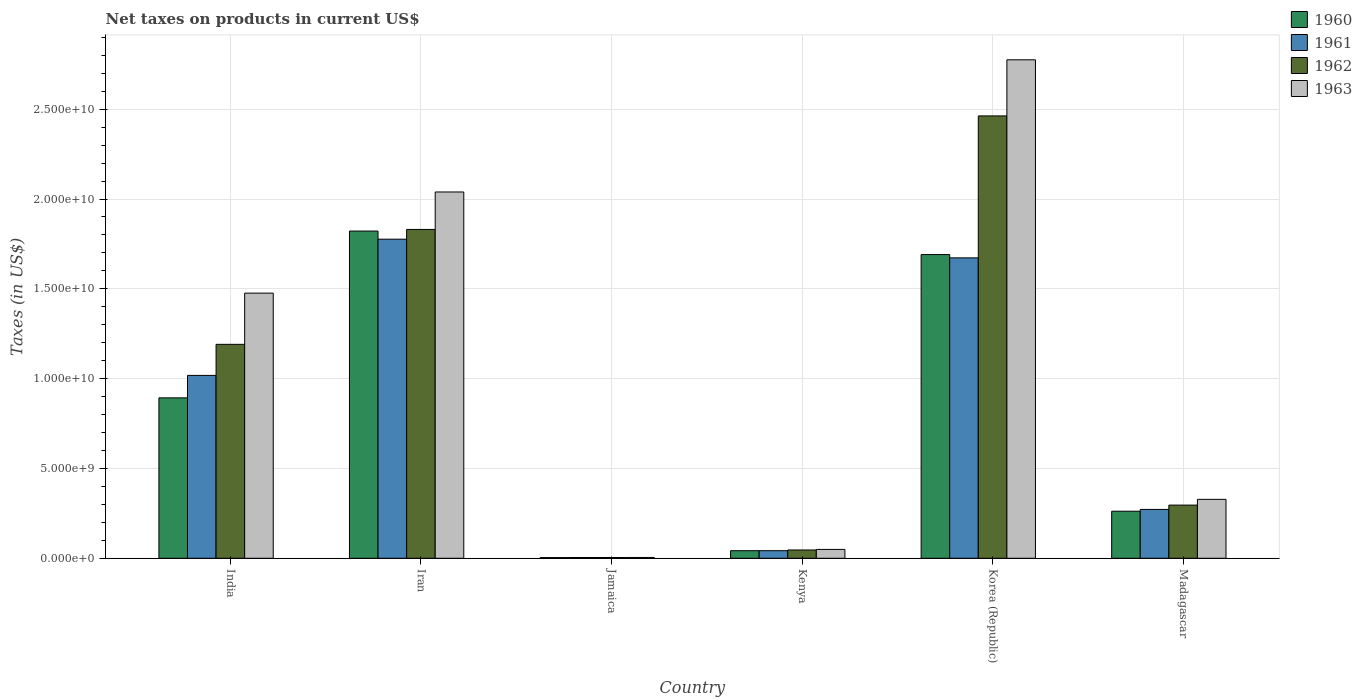How many different coloured bars are there?
Your answer should be compact. 4. How many groups of bars are there?
Offer a terse response. 6. Are the number of bars per tick equal to the number of legend labels?
Make the answer very short. Yes. Are the number of bars on each tick of the X-axis equal?
Provide a succinct answer. Yes. How many bars are there on the 4th tick from the left?
Your response must be concise. 4. How many bars are there on the 5th tick from the right?
Your answer should be very brief. 4. What is the label of the 5th group of bars from the left?
Offer a very short reply. Korea (Republic). In how many cases, is the number of bars for a given country not equal to the number of legend labels?
Your answer should be compact. 0. What is the net taxes on products in 1962 in India?
Make the answer very short. 1.19e+1. Across all countries, what is the maximum net taxes on products in 1960?
Offer a terse response. 1.82e+1. Across all countries, what is the minimum net taxes on products in 1963?
Keep it short and to the point. 4.54e+07. In which country was the net taxes on products in 1960 maximum?
Keep it short and to the point. Iran. In which country was the net taxes on products in 1963 minimum?
Offer a very short reply. Jamaica. What is the total net taxes on products in 1961 in the graph?
Offer a terse response. 4.79e+1. What is the difference between the net taxes on products in 1960 in India and that in Korea (Republic)?
Your response must be concise. -7.98e+09. What is the difference between the net taxes on products in 1961 in Madagascar and the net taxes on products in 1960 in Kenya?
Offer a terse response. 2.30e+09. What is the average net taxes on products in 1960 per country?
Provide a succinct answer. 7.86e+09. What is the difference between the net taxes on products of/in 1962 and net taxes on products of/in 1961 in India?
Provide a succinct answer. 1.73e+09. What is the ratio of the net taxes on products in 1963 in Kenya to that in Korea (Republic)?
Keep it short and to the point. 0.02. Is the net taxes on products in 1963 in India less than that in Madagascar?
Your answer should be very brief. No. What is the difference between the highest and the second highest net taxes on products in 1962?
Keep it short and to the point. -1.27e+1. What is the difference between the highest and the lowest net taxes on products in 1961?
Your answer should be very brief. 1.77e+1. In how many countries, is the net taxes on products in 1961 greater than the average net taxes on products in 1961 taken over all countries?
Provide a short and direct response. 3. Is the sum of the net taxes on products in 1960 in India and Kenya greater than the maximum net taxes on products in 1961 across all countries?
Provide a short and direct response. No. Is it the case that in every country, the sum of the net taxes on products in 1961 and net taxes on products in 1960 is greater than the sum of net taxes on products in 1962 and net taxes on products in 1963?
Offer a terse response. No. What does the 3rd bar from the left in India represents?
Offer a terse response. 1962. Is it the case that in every country, the sum of the net taxes on products in 1961 and net taxes on products in 1960 is greater than the net taxes on products in 1963?
Provide a succinct answer. Yes. Are all the bars in the graph horizontal?
Provide a succinct answer. No. How many countries are there in the graph?
Offer a very short reply. 6. Does the graph contain any zero values?
Your answer should be compact. No. Where does the legend appear in the graph?
Make the answer very short. Top right. How many legend labels are there?
Ensure brevity in your answer.  4. How are the legend labels stacked?
Provide a succinct answer. Vertical. What is the title of the graph?
Ensure brevity in your answer.  Net taxes on products in current US$. What is the label or title of the Y-axis?
Your answer should be compact. Taxes (in US$). What is the Taxes (in US$) of 1960 in India?
Your answer should be very brief. 8.93e+09. What is the Taxes (in US$) of 1961 in India?
Your response must be concise. 1.02e+1. What is the Taxes (in US$) in 1962 in India?
Your answer should be compact. 1.19e+1. What is the Taxes (in US$) of 1963 in India?
Provide a succinct answer. 1.48e+1. What is the Taxes (in US$) of 1960 in Iran?
Your answer should be very brief. 1.82e+1. What is the Taxes (in US$) in 1961 in Iran?
Ensure brevity in your answer.  1.78e+1. What is the Taxes (in US$) in 1962 in Iran?
Give a very brief answer. 1.83e+1. What is the Taxes (in US$) of 1963 in Iran?
Give a very brief answer. 2.04e+1. What is the Taxes (in US$) of 1960 in Jamaica?
Make the answer very short. 3.93e+07. What is the Taxes (in US$) in 1961 in Jamaica?
Provide a succinct answer. 4.26e+07. What is the Taxes (in US$) in 1962 in Jamaica?
Your response must be concise. 4.35e+07. What is the Taxes (in US$) in 1963 in Jamaica?
Provide a short and direct response. 4.54e+07. What is the Taxes (in US$) of 1960 in Kenya?
Provide a short and direct response. 4.21e+08. What is the Taxes (in US$) in 1961 in Kenya?
Your answer should be very brief. 4.22e+08. What is the Taxes (in US$) of 1962 in Kenya?
Your answer should be compact. 4.62e+08. What is the Taxes (in US$) of 1963 in Kenya?
Provide a short and direct response. 4.93e+08. What is the Taxes (in US$) in 1960 in Korea (Republic)?
Make the answer very short. 1.69e+1. What is the Taxes (in US$) of 1961 in Korea (Republic)?
Your answer should be compact. 1.67e+1. What is the Taxes (in US$) in 1962 in Korea (Republic)?
Give a very brief answer. 2.46e+1. What is the Taxes (in US$) of 1963 in Korea (Republic)?
Make the answer very short. 2.77e+1. What is the Taxes (in US$) in 1960 in Madagascar?
Ensure brevity in your answer.  2.62e+09. What is the Taxes (in US$) in 1961 in Madagascar?
Offer a very short reply. 2.72e+09. What is the Taxes (in US$) in 1962 in Madagascar?
Give a very brief answer. 2.96e+09. What is the Taxes (in US$) in 1963 in Madagascar?
Your answer should be very brief. 3.28e+09. Across all countries, what is the maximum Taxes (in US$) in 1960?
Your response must be concise. 1.82e+1. Across all countries, what is the maximum Taxes (in US$) of 1961?
Provide a succinct answer. 1.78e+1. Across all countries, what is the maximum Taxes (in US$) of 1962?
Offer a terse response. 2.46e+1. Across all countries, what is the maximum Taxes (in US$) in 1963?
Provide a short and direct response. 2.77e+1. Across all countries, what is the minimum Taxes (in US$) of 1960?
Provide a succinct answer. 3.93e+07. Across all countries, what is the minimum Taxes (in US$) in 1961?
Your response must be concise. 4.26e+07. Across all countries, what is the minimum Taxes (in US$) of 1962?
Your answer should be compact. 4.35e+07. Across all countries, what is the minimum Taxes (in US$) in 1963?
Make the answer very short. 4.54e+07. What is the total Taxes (in US$) in 1960 in the graph?
Your answer should be very brief. 4.71e+1. What is the total Taxes (in US$) of 1961 in the graph?
Provide a short and direct response. 4.79e+1. What is the total Taxes (in US$) in 1962 in the graph?
Keep it short and to the point. 5.83e+1. What is the total Taxes (in US$) of 1963 in the graph?
Offer a very short reply. 6.67e+1. What is the difference between the Taxes (in US$) in 1960 in India and that in Iran?
Keep it short and to the point. -9.29e+09. What is the difference between the Taxes (in US$) of 1961 in India and that in Iran?
Ensure brevity in your answer.  -7.58e+09. What is the difference between the Taxes (in US$) of 1962 in India and that in Iran?
Ensure brevity in your answer.  -6.40e+09. What is the difference between the Taxes (in US$) in 1963 in India and that in Iran?
Ensure brevity in your answer.  -5.63e+09. What is the difference between the Taxes (in US$) in 1960 in India and that in Jamaica?
Ensure brevity in your answer.  8.89e+09. What is the difference between the Taxes (in US$) of 1961 in India and that in Jamaica?
Provide a short and direct response. 1.01e+1. What is the difference between the Taxes (in US$) of 1962 in India and that in Jamaica?
Your answer should be compact. 1.19e+1. What is the difference between the Taxes (in US$) of 1963 in India and that in Jamaica?
Make the answer very short. 1.47e+1. What is the difference between the Taxes (in US$) in 1960 in India and that in Kenya?
Make the answer very short. 8.51e+09. What is the difference between the Taxes (in US$) of 1961 in India and that in Kenya?
Make the answer very short. 9.76e+09. What is the difference between the Taxes (in US$) in 1962 in India and that in Kenya?
Your answer should be compact. 1.14e+1. What is the difference between the Taxes (in US$) in 1963 in India and that in Kenya?
Ensure brevity in your answer.  1.43e+1. What is the difference between the Taxes (in US$) of 1960 in India and that in Korea (Republic)?
Your answer should be compact. -7.98e+09. What is the difference between the Taxes (in US$) in 1961 in India and that in Korea (Republic)?
Make the answer very short. -6.54e+09. What is the difference between the Taxes (in US$) in 1962 in India and that in Korea (Republic)?
Provide a succinct answer. -1.27e+1. What is the difference between the Taxes (in US$) of 1963 in India and that in Korea (Republic)?
Keep it short and to the point. -1.30e+1. What is the difference between the Taxes (in US$) in 1960 in India and that in Madagascar?
Ensure brevity in your answer.  6.31e+09. What is the difference between the Taxes (in US$) in 1961 in India and that in Madagascar?
Your answer should be very brief. 7.46e+09. What is the difference between the Taxes (in US$) in 1962 in India and that in Madagascar?
Provide a short and direct response. 8.95e+09. What is the difference between the Taxes (in US$) in 1963 in India and that in Madagascar?
Make the answer very short. 1.15e+1. What is the difference between the Taxes (in US$) in 1960 in Iran and that in Jamaica?
Offer a very short reply. 1.82e+1. What is the difference between the Taxes (in US$) in 1961 in Iran and that in Jamaica?
Offer a very short reply. 1.77e+1. What is the difference between the Taxes (in US$) of 1962 in Iran and that in Jamaica?
Offer a terse response. 1.83e+1. What is the difference between the Taxes (in US$) of 1963 in Iran and that in Jamaica?
Keep it short and to the point. 2.03e+1. What is the difference between the Taxes (in US$) of 1960 in Iran and that in Kenya?
Make the answer very short. 1.78e+1. What is the difference between the Taxes (in US$) in 1961 in Iran and that in Kenya?
Offer a very short reply. 1.73e+1. What is the difference between the Taxes (in US$) in 1962 in Iran and that in Kenya?
Offer a terse response. 1.78e+1. What is the difference between the Taxes (in US$) in 1963 in Iran and that in Kenya?
Give a very brief answer. 1.99e+1. What is the difference between the Taxes (in US$) of 1960 in Iran and that in Korea (Republic)?
Keep it short and to the point. 1.31e+09. What is the difference between the Taxes (in US$) in 1961 in Iran and that in Korea (Republic)?
Keep it short and to the point. 1.04e+09. What is the difference between the Taxes (in US$) of 1962 in Iran and that in Korea (Republic)?
Your answer should be very brief. -6.32e+09. What is the difference between the Taxes (in US$) of 1963 in Iran and that in Korea (Republic)?
Keep it short and to the point. -7.36e+09. What is the difference between the Taxes (in US$) of 1960 in Iran and that in Madagascar?
Ensure brevity in your answer.  1.56e+1. What is the difference between the Taxes (in US$) in 1961 in Iran and that in Madagascar?
Offer a terse response. 1.50e+1. What is the difference between the Taxes (in US$) in 1962 in Iran and that in Madagascar?
Your answer should be very brief. 1.53e+1. What is the difference between the Taxes (in US$) of 1963 in Iran and that in Madagascar?
Your answer should be compact. 1.71e+1. What is the difference between the Taxes (in US$) in 1960 in Jamaica and that in Kenya?
Give a very brief answer. -3.82e+08. What is the difference between the Taxes (in US$) in 1961 in Jamaica and that in Kenya?
Keep it short and to the point. -3.79e+08. What is the difference between the Taxes (in US$) of 1962 in Jamaica and that in Kenya?
Keep it short and to the point. -4.18e+08. What is the difference between the Taxes (in US$) of 1963 in Jamaica and that in Kenya?
Your answer should be compact. -4.48e+08. What is the difference between the Taxes (in US$) of 1960 in Jamaica and that in Korea (Republic)?
Offer a terse response. -1.69e+1. What is the difference between the Taxes (in US$) in 1961 in Jamaica and that in Korea (Republic)?
Offer a very short reply. -1.67e+1. What is the difference between the Taxes (in US$) in 1962 in Jamaica and that in Korea (Republic)?
Give a very brief answer. -2.46e+1. What is the difference between the Taxes (in US$) in 1963 in Jamaica and that in Korea (Republic)?
Keep it short and to the point. -2.77e+1. What is the difference between the Taxes (in US$) of 1960 in Jamaica and that in Madagascar?
Offer a terse response. -2.58e+09. What is the difference between the Taxes (in US$) in 1961 in Jamaica and that in Madagascar?
Keep it short and to the point. -2.68e+09. What is the difference between the Taxes (in US$) in 1962 in Jamaica and that in Madagascar?
Your answer should be very brief. -2.92e+09. What is the difference between the Taxes (in US$) in 1963 in Jamaica and that in Madagascar?
Your answer should be very brief. -3.23e+09. What is the difference between the Taxes (in US$) of 1960 in Kenya and that in Korea (Republic)?
Keep it short and to the point. -1.65e+1. What is the difference between the Taxes (in US$) of 1961 in Kenya and that in Korea (Republic)?
Your response must be concise. -1.63e+1. What is the difference between the Taxes (in US$) in 1962 in Kenya and that in Korea (Republic)?
Ensure brevity in your answer.  -2.42e+1. What is the difference between the Taxes (in US$) of 1963 in Kenya and that in Korea (Republic)?
Your response must be concise. -2.73e+1. What is the difference between the Taxes (in US$) in 1960 in Kenya and that in Madagascar?
Offer a terse response. -2.20e+09. What is the difference between the Taxes (in US$) in 1961 in Kenya and that in Madagascar?
Offer a terse response. -2.30e+09. What is the difference between the Taxes (in US$) of 1962 in Kenya and that in Madagascar?
Your response must be concise. -2.50e+09. What is the difference between the Taxes (in US$) of 1963 in Kenya and that in Madagascar?
Provide a short and direct response. -2.79e+09. What is the difference between the Taxes (in US$) of 1960 in Korea (Republic) and that in Madagascar?
Your response must be concise. 1.43e+1. What is the difference between the Taxes (in US$) of 1961 in Korea (Republic) and that in Madagascar?
Your answer should be compact. 1.40e+1. What is the difference between the Taxes (in US$) of 1962 in Korea (Republic) and that in Madagascar?
Make the answer very short. 2.17e+1. What is the difference between the Taxes (in US$) of 1963 in Korea (Republic) and that in Madagascar?
Ensure brevity in your answer.  2.45e+1. What is the difference between the Taxes (in US$) of 1960 in India and the Taxes (in US$) of 1961 in Iran?
Ensure brevity in your answer.  -8.83e+09. What is the difference between the Taxes (in US$) of 1960 in India and the Taxes (in US$) of 1962 in Iran?
Ensure brevity in your answer.  -9.38e+09. What is the difference between the Taxes (in US$) in 1960 in India and the Taxes (in US$) in 1963 in Iran?
Offer a terse response. -1.15e+1. What is the difference between the Taxes (in US$) in 1961 in India and the Taxes (in US$) in 1962 in Iran?
Your answer should be very brief. -8.13e+09. What is the difference between the Taxes (in US$) of 1961 in India and the Taxes (in US$) of 1963 in Iran?
Give a very brief answer. -1.02e+1. What is the difference between the Taxes (in US$) of 1962 in India and the Taxes (in US$) of 1963 in Iran?
Offer a very short reply. -8.48e+09. What is the difference between the Taxes (in US$) of 1960 in India and the Taxes (in US$) of 1961 in Jamaica?
Offer a terse response. 8.89e+09. What is the difference between the Taxes (in US$) in 1960 in India and the Taxes (in US$) in 1962 in Jamaica?
Offer a very short reply. 8.89e+09. What is the difference between the Taxes (in US$) in 1960 in India and the Taxes (in US$) in 1963 in Jamaica?
Your response must be concise. 8.88e+09. What is the difference between the Taxes (in US$) of 1961 in India and the Taxes (in US$) of 1962 in Jamaica?
Your answer should be very brief. 1.01e+1. What is the difference between the Taxes (in US$) in 1961 in India and the Taxes (in US$) in 1963 in Jamaica?
Your response must be concise. 1.01e+1. What is the difference between the Taxes (in US$) in 1962 in India and the Taxes (in US$) in 1963 in Jamaica?
Your answer should be compact. 1.19e+1. What is the difference between the Taxes (in US$) of 1960 in India and the Taxes (in US$) of 1961 in Kenya?
Your answer should be very brief. 8.51e+09. What is the difference between the Taxes (in US$) of 1960 in India and the Taxes (in US$) of 1962 in Kenya?
Provide a succinct answer. 8.47e+09. What is the difference between the Taxes (in US$) in 1960 in India and the Taxes (in US$) in 1963 in Kenya?
Provide a succinct answer. 8.44e+09. What is the difference between the Taxes (in US$) of 1961 in India and the Taxes (in US$) of 1962 in Kenya?
Your response must be concise. 9.72e+09. What is the difference between the Taxes (in US$) of 1961 in India and the Taxes (in US$) of 1963 in Kenya?
Make the answer very short. 9.69e+09. What is the difference between the Taxes (in US$) in 1962 in India and the Taxes (in US$) in 1963 in Kenya?
Provide a succinct answer. 1.14e+1. What is the difference between the Taxes (in US$) in 1960 in India and the Taxes (in US$) in 1961 in Korea (Republic)?
Your answer should be very brief. -7.79e+09. What is the difference between the Taxes (in US$) of 1960 in India and the Taxes (in US$) of 1962 in Korea (Republic)?
Your answer should be very brief. -1.57e+1. What is the difference between the Taxes (in US$) in 1960 in India and the Taxes (in US$) in 1963 in Korea (Republic)?
Provide a succinct answer. -1.88e+1. What is the difference between the Taxes (in US$) of 1961 in India and the Taxes (in US$) of 1962 in Korea (Republic)?
Give a very brief answer. -1.44e+1. What is the difference between the Taxes (in US$) in 1961 in India and the Taxes (in US$) in 1963 in Korea (Republic)?
Ensure brevity in your answer.  -1.76e+1. What is the difference between the Taxes (in US$) of 1962 in India and the Taxes (in US$) of 1963 in Korea (Republic)?
Give a very brief answer. -1.58e+1. What is the difference between the Taxes (in US$) of 1960 in India and the Taxes (in US$) of 1961 in Madagascar?
Your answer should be very brief. 6.21e+09. What is the difference between the Taxes (in US$) in 1960 in India and the Taxes (in US$) in 1962 in Madagascar?
Provide a succinct answer. 5.97e+09. What is the difference between the Taxes (in US$) of 1960 in India and the Taxes (in US$) of 1963 in Madagascar?
Offer a very short reply. 5.65e+09. What is the difference between the Taxes (in US$) of 1961 in India and the Taxes (in US$) of 1962 in Madagascar?
Offer a terse response. 7.22e+09. What is the difference between the Taxes (in US$) in 1961 in India and the Taxes (in US$) in 1963 in Madagascar?
Make the answer very short. 6.90e+09. What is the difference between the Taxes (in US$) of 1962 in India and the Taxes (in US$) of 1963 in Madagascar?
Your response must be concise. 8.63e+09. What is the difference between the Taxes (in US$) of 1960 in Iran and the Taxes (in US$) of 1961 in Jamaica?
Ensure brevity in your answer.  1.82e+1. What is the difference between the Taxes (in US$) in 1960 in Iran and the Taxes (in US$) in 1962 in Jamaica?
Offer a terse response. 1.82e+1. What is the difference between the Taxes (in US$) in 1960 in Iran and the Taxes (in US$) in 1963 in Jamaica?
Offer a terse response. 1.82e+1. What is the difference between the Taxes (in US$) of 1961 in Iran and the Taxes (in US$) of 1962 in Jamaica?
Keep it short and to the point. 1.77e+1. What is the difference between the Taxes (in US$) in 1961 in Iran and the Taxes (in US$) in 1963 in Jamaica?
Provide a short and direct response. 1.77e+1. What is the difference between the Taxes (in US$) of 1962 in Iran and the Taxes (in US$) of 1963 in Jamaica?
Your answer should be compact. 1.83e+1. What is the difference between the Taxes (in US$) in 1960 in Iran and the Taxes (in US$) in 1961 in Kenya?
Offer a terse response. 1.78e+1. What is the difference between the Taxes (in US$) in 1960 in Iran and the Taxes (in US$) in 1962 in Kenya?
Provide a succinct answer. 1.78e+1. What is the difference between the Taxes (in US$) in 1960 in Iran and the Taxes (in US$) in 1963 in Kenya?
Give a very brief answer. 1.77e+1. What is the difference between the Taxes (in US$) in 1961 in Iran and the Taxes (in US$) in 1962 in Kenya?
Provide a succinct answer. 1.73e+1. What is the difference between the Taxes (in US$) in 1961 in Iran and the Taxes (in US$) in 1963 in Kenya?
Give a very brief answer. 1.73e+1. What is the difference between the Taxes (in US$) of 1962 in Iran and the Taxes (in US$) of 1963 in Kenya?
Your answer should be very brief. 1.78e+1. What is the difference between the Taxes (in US$) in 1960 in Iran and the Taxes (in US$) in 1961 in Korea (Republic)?
Give a very brief answer. 1.49e+09. What is the difference between the Taxes (in US$) of 1960 in Iran and the Taxes (in US$) of 1962 in Korea (Republic)?
Your answer should be compact. -6.41e+09. What is the difference between the Taxes (in US$) of 1960 in Iran and the Taxes (in US$) of 1963 in Korea (Republic)?
Make the answer very short. -9.53e+09. What is the difference between the Taxes (in US$) of 1961 in Iran and the Taxes (in US$) of 1962 in Korea (Republic)?
Make the answer very short. -6.86e+09. What is the difference between the Taxes (in US$) of 1961 in Iran and the Taxes (in US$) of 1963 in Korea (Republic)?
Provide a short and direct response. -9.99e+09. What is the difference between the Taxes (in US$) of 1962 in Iran and the Taxes (in US$) of 1963 in Korea (Republic)?
Give a very brief answer. -9.44e+09. What is the difference between the Taxes (in US$) of 1960 in Iran and the Taxes (in US$) of 1961 in Madagascar?
Ensure brevity in your answer.  1.55e+1. What is the difference between the Taxes (in US$) of 1960 in Iran and the Taxes (in US$) of 1962 in Madagascar?
Make the answer very short. 1.53e+1. What is the difference between the Taxes (in US$) of 1960 in Iran and the Taxes (in US$) of 1963 in Madagascar?
Your answer should be very brief. 1.49e+1. What is the difference between the Taxes (in US$) of 1961 in Iran and the Taxes (in US$) of 1962 in Madagascar?
Offer a terse response. 1.48e+1. What is the difference between the Taxes (in US$) of 1961 in Iran and the Taxes (in US$) of 1963 in Madagascar?
Make the answer very short. 1.45e+1. What is the difference between the Taxes (in US$) of 1962 in Iran and the Taxes (in US$) of 1963 in Madagascar?
Keep it short and to the point. 1.50e+1. What is the difference between the Taxes (in US$) of 1960 in Jamaica and the Taxes (in US$) of 1961 in Kenya?
Your response must be concise. -3.83e+08. What is the difference between the Taxes (in US$) of 1960 in Jamaica and the Taxes (in US$) of 1962 in Kenya?
Your response must be concise. -4.22e+08. What is the difference between the Taxes (in US$) in 1960 in Jamaica and the Taxes (in US$) in 1963 in Kenya?
Your response must be concise. -4.54e+08. What is the difference between the Taxes (in US$) of 1961 in Jamaica and the Taxes (in US$) of 1962 in Kenya?
Your answer should be very brief. -4.19e+08. What is the difference between the Taxes (in US$) in 1961 in Jamaica and the Taxes (in US$) in 1963 in Kenya?
Keep it short and to the point. -4.50e+08. What is the difference between the Taxes (in US$) of 1962 in Jamaica and the Taxes (in US$) of 1963 in Kenya?
Ensure brevity in your answer.  -4.50e+08. What is the difference between the Taxes (in US$) in 1960 in Jamaica and the Taxes (in US$) in 1961 in Korea (Republic)?
Offer a very short reply. -1.67e+1. What is the difference between the Taxes (in US$) of 1960 in Jamaica and the Taxes (in US$) of 1962 in Korea (Republic)?
Give a very brief answer. -2.46e+1. What is the difference between the Taxes (in US$) of 1960 in Jamaica and the Taxes (in US$) of 1963 in Korea (Republic)?
Keep it short and to the point. -2.77e+1. What is the difference between the Taxes (in US$) of 1961 in Jamaica and the Taxes (in US$) of 1962 in Korea (Republic)?
Keep it short and to the point. -2.46e+1. What is the difference between the Taxes (in US$) of 1961 in Jamaica and the Taxes (in US$) of 1963 in Korea (Republic)?
Keep it short and to the point. -2.77e+1. What is the difference between the Taxes (in US$) in 1962 in Jamaica and the Taxes (in US$) in 1963 in Korea (Republic)?
Ensure brevity in your answer.  -2.77e+1. What is the difference between the Taxes (in US$) of 1960 in Jamaica and the Taxes (in US$) of 1961 in Madagascar?
Your answer should be very brief. -2.68e+09. What is the difference between the Taxes (in US$) of 1960 in Jamaica and the Taxes (in US$) of 1962 in Madagascar?
Make the answer very short. -2.92e+09. What is the difference between the Taxes (in US$) in 1960 in Jamaica and the Taxes (in US$) in 1963 in Madagascar?
Offer a terse response. -3.24e+09. What is the difference between the Taxes (in US$) of 1961 in Jamaica and the Taxes (in US$) of 1962 in Madagascar?
Give a very brief answer. -2.92e+09. What is the difference between the Taxes (in US$) of 1961 in Jamaica and the Taxes (in US$) of 1963 in Madagascar?
Make the answer very short. -3.24e+09. What is the difference between the Taxes (in US$) in 1962 in Jamaica and the Taxes (in US$) in 1963 in Madagascar?
Give a very brief answer. -3.24e+09. What is the difference between the Taxes (in US$) of 1960 in Kenya and the Taxes (in US$) of 1961 in Korea (Republic)?
Your answer should be very brief. -1.63e+1. What is the difference between the Taxes (in US$) of 1960 in Kenya and the Taxes (in US$) of 1962 in Korea (Republic)?
Provide a short and direct response. -2.42e+1. What is the difference between the Taxes (in US$) in 1960 in Kenya and the Taxes (in US$) in 1963 in Korea (Republic)?
Make the answer very short. -2.73e+1. What is the difference between the Taxes (in US$) in 1961 in Kenya and the Taxes (in US$) in 1962 in Korea (Republic)?
Provide a succinct answer. -2.42e+1. What is the difference between the Taxes (in US$) in 1961 in Kenya and the Taxes (in US$) in 1963 in Korea (Republic)?
Provide a succinct answer. -2.73e+1. What is the difference between the Taxes (in US$) of 1962 in Kenya and the Taxes (in US$) of 1963 in Korea (Republic)?
Offer a very short reply. -2.73e+1. What is the difference between the Taxes (in US$) of 1960 in Kenya and the Taxes (in US$) of 1961 in Madagascar?
Provide a short and direct response. -2.30e+09. What is the difference between the Taxes (in US$) of 1960 in Kenya and the Taxes (in US$) of 1962 in Madagascar?
Make the answer very short. -2.54e+09. What is the difference between the Taxes (in US$) in 1960 in Kenya and the Taxes (in US$) in 1963 in Madagascar?
Offer a terse response. -2.86e+09. What is the difference between the Taxes (in US$) in 1961 in Kenya and the Taxes (in US$) in 1962 in Madagascar?
Give a very brief answer. -2.54e+09. What is the difference between the Taxes (in US$) of 1961 in Kenya and the Taxes (in US$) of 1963 in Madagascar?
Keep it short and to the point. -2.86e+09. What is the difference between the Taxes (in US$) of 1962 in Kenya and the Taxes (in US$) of 1963 in Madagascar?
Provide a succinct answer. -2.82e+09. What is the difference between the Taxes (in US$) in 1960 in Korea (Republic) and the Taxes (in US$) in 1961 in Madagascar?
Keep it short and to the point. 1.42e+1. What is the difference between the Taxes (in US$) of 1960 in Korea (Republic) and the Taxes (in US$) of 1962 in Madagascar?
Offer a very short reply. 1.39e+1. What is the difference between the Taxes (in US$) of 1960 in Korea (Republic) and the Taxes (in US$) of 1963 in Madagascar?
Your answer should be compact. 1.36e+1. What is the difference between the Taxes (in US$) of 1961 in Korea (Republic) and the Taxes (in US$) of 1962 in Madagascar?
Ensure brevity in your answer.  1.38e+1. What is the difference between the Taxes (in US$) in 1961 in Korea (Republic) and the Taxes (in US$) in 1963 in Madagascar?
Your answer should be very brief. 1.34e+1. What is the difference between the Taxes (in US$) of 1962 in Korea (Republic) and the Taxes (in US$) of 1963 in Madagascar?
Make the answer very short. 2.13e+1. What is the average Taxes (in US$) in 1960 per country?
Your answer should be compact. 7.86e+09. What is the average Taxes (in US$) in 1961 per country?
Provide a short and direct response. 7.98e+09. What is the average Taxes (in US$) of 1962 per country?
Provide a succinct answer. 9.72e+09. What is the average Taxes (in US$) of 1963 per country?
Keep it short and to the point. 1.11e+1. What is the difference between the Taxes (in US$) of 1960 and Taxes (in US$) of 1961 in India?
Offer a terse response. -1.25e+09. What is the difference between the Taxes (in US$) of 1960 and Taxes (in US$) of 1962 in India?
Your answer should be compact. -2.98e+09. What is the difference between the Taxes (in US$) of 1960 and Taxes (in US$) of 1963 in India?
Your answer should be very brief. -5.83e+09. What is the difference between the Taxes (in US$) in 1961 and Taxes (in US$) in 1962 in India?
Your answer should be very brief. -1.73e+09. What is the difference between the Taxes (in US$) of 1961 and Taxes (in US$) of 1963 in India?
Your answer should be very brief. -4.58e+09. What is the difference between the Taxes (in US$) of 1962 and Taxes (in US$) of 1963 in India?
Your answer should be very brief. -2.85e+09. What is the difference between the Taxes (in US$) of 1960 and Taxes (in US$) of 1961 in Iran?
Your answer should be very brief. 4.53e+08. What is the difference between the Taxes (in US$) of 1960 and Taxes (in US$) of 1962 in Iran?
Offer a very short reply. -9.06e+07. What is the difference between the Taxes (in US$) in 1960 and Taxes (in US$) in 1963 in Iran?
Keep it short and to the point. -2.18e+09. What is the difference between the Taxes (in US$) of 1961 and Taxes (in US$) of 1962 in Iran?
Provide a short and direct response. -5.44e+08. What is the difference between the Taxes (in US$) of 1961 and Taxes (in US$) of 1963 in Iran?
Ensure brevity in your answer.  -2.63e+09. What is the difference between the Taxes (in US$) in 1962 and Taxes (in US$) in 1963 in Iran?
Provide a succinct answer. -2.08e+09. What is the difference between the Taxes (in US$) of 1960 and Taxes (in US$) of 1961 in Jamaica?
Ensure brevity in your answer.  -3.30e+06. What is the difference between the Taxes (in US$) of 1960 and Taxes (in US$) of 1962 in Jamaica?
Provide a succinct answer. -4.20e+06. What is the difference between the Taxes (in US$) in 1960 and Taxes (in US$) in 1963 in Jamaica?
Provide a succinct answer. -6.10e+06. What is the difference between the Taxes (in US$) of 1961 and Taxes (in US$) of 1962 in Jamaica?
Give a very brief answer. -9.00e+05. What is the difference between the Taxes (in US$) in 1961 and Taxes (in US$) in 1963 in Jamaica?
Keep it short and to the point. -2.80e+06. What is the difference between the Taxes (in US$) in 1962 and Taxes (in US$) in 1963 in Jamaica?
Provide a succinct answer. -1.90e+06. What is the difference between the Taxes (in US$) in 1960 and Taxes (in US$) in 1961 in Kenya?
Your response must be concise. -1.00e+06. What is the difference between the Taxes (in US$) of 1960 and Taxes (in US$) of 1962 in Kenya?
Offer a very short reply. -4.09e+07. What is the difference between the Taxes (in US$) of 1960 and Taxes (in US$) of 1963 in Kenya?
Give a very brief answer. -7.21e+07. What is the difference between the Taxes (in US$) of 1961 and Taxes (in US$) of 1962 in Kenya?
Give a very brief answer. -3.99e+07. What is the difference between the Taxes (in US$) in 1961 and Taxes (in US$) in 1963 in Kenya?
Provide a succinct answer. -7.11e+07. What is the difference between the Taxes (in US$) in 1962 and Taxes (in US$) in 1963 in Kenya?
Your response must be concise. -3.12e+07. What is the difference between the Taxes (in US$) of 1960 and Taxes (in US$) of 1961 in Korea (Republic)?
Give a very brief answer. 1.84e+08. What is the difference between the Taxes (in US$) of 1960 and Taxes (in US$) of 1962 in Korea (Republic)?
Provide a short and direct response. -7.72e+09. What is the difference between the Taxes (in US$) in 1960 and Taxes (in US$) in 1963 in Korea (Republic)?
Give a very brief answer. -1.08e+1. What is the difference between the Taxes (in US$) of 1961 and Taxes (in US$) of 1962 in Korea (Republic)?
Ensure brevity in your answer.  -7.90e+09. What is the difference between the Taxes (in US$) of 1961 and Taxes (in US$) of 1963 in Korea (Republic)?
Offer a very short reply. -1.10e+1. What is the difference between the Taxes (in US$) in 1962 and Taxes (in US$) in 1963 in Korea (Republic)?
Offer a very short reply. -3.12e+09. What is the difference between the Taxes (in US$) in 1960 and Taxes (in US$) in 1961 in Madagascar?
Your response must be concise. -1.00e+08. What is the difference between the Taxes (in US$) in 1960 and Taxes (in US$) in 1962 in Madagascar?
Make the answer very short. -3.40e+08. What is the difference between the Taxes (in US$) in 1960 and Taxes (in US$) in 1963 in Madagascar?
Your answer should be compact. -6.60e+08. What is the difference between the Taxes (in US$) in 1961 and Taxes (in US$) in 1962 in Madagascar?
Provide a short and direct response. -2.40e+08. What is the difference between the Taxes (in US$) in 1961 and Taxes (in US$) in 1963 in Madagascar?
Provide a succinct answer. -5.60e+08. What is the difference between the Taxes (in US$) of 1962 and Taxes (in US$) of 1963 in Madagascar?
Your answer should be very brief. -3.20e+08. What is the ratio of the Taxes (in US$) of 1960 in India to that in Iran?
Provide a short and direct response. 0.49. What is the ratio of the Taxes (in US$) in 1961 in India to that in Iran?
Give a very brief answer. 0.57. What is the ratio of the Taxes (in US$) in 1962 in India to that in Iran?
Provide a succinct answer. 0.65. What is the ratio of the Taxes (in US$) in 1963 in India to that in Iran?
Make the answer very short. 0.72. What is the ratio of the Taxes (in US$) of 1960 in India to that in Jamaica?
Make the answer very short. 227.23. What is the ratio of the Taxes (in US$) in 1961 in India to that in Jamaica?
Make the answer very short. 238.97. What is the ratio of the Taxes (in US$) in 1962 in India to that in Jamaica?
Ensure brevity in your answer.  273.79. What is the ratio of the Taxes (in US$) in 1963 in India to that in Jamaica?
Ensure brevity in your answer.  325.11. What is the ratio of the Taxes (in US$) in 1960 in India to that in Kenya?
Make the answer very short. 21.22. What is the ratio of the Taxes (in US$) in 1961 in India to that in Kenya?
Offer a terse response. 24.13. What is the ratio of the Taxes (in US$) in 1962 in India to that in Kenya?
Give a very brief answer. 25.79. What is the ratio of the Taxes (in US$) of 1963 in India to that in Kenya?
Your answer should be very brief. 29.94. What is the ratio of the Taxes (in US$) of 1960 in India to that in Korea (Republic)?
Offer a very short reply. 0.53. What is the ratio of the Taxes (in US$) in 1961 in India to that in Korea (Republic)?
Provide a short and direct response. 0.61. What is the ratio of the Taxes (in US$) of 1962 in India to that in Korea (Republic)?
Your response must be concise. 0.48. What is the ratio of the Taxes (in US$) of 1963 in India to that in Korea (Republic)?
Your answer should be compact. 0.53. What is the ratio of the Taxes (in US$) of 1960 in India to that in Madagascar?
Make the answer very short. 3.41. What is the ratio of the Taxes (in US$) in 1961 in India to that in Madagascar?
Your response must be concise. 3.74. What is the ratio of the Taxes (in US$) in 1962 in India to that in Madagascar?
Your answer should be very brief. 4.02. What is the ratio of the Taxes (in US$) of 1963 in India to that in Madagascar?
Your answer should be compact. 4.5. What is the ratio of the Taxes (in US$) of 1960 in Iran to that in Jamaica?
Offer a terse response. 463.51. What is the ratio of the Taxes (in US$) of 1961 in Iran to that in Jamaica?
Provide a short and direct response. 416.97. What is the ratio of the Taxes (in US$) of 1962 in Iran to that in Jamaica?
Your response must be concise. 420.84. What is the ratio of the Taxes (in US$) in 1963 in Iran to that in Jamaica?
Give a very brief answer. 449.14. What is the ratio of the Taxes (in US$) of 1960 in Iran to that in Kenya?
Offer a very short reply. 43.28. What is the ratio of the Taxes (in US$) in 1961 in Iran to that in Kenya?
Your answer should be compact. 42.1. What is the ratio of the Taxes (in US$) of 1962 in Iran to that in Kenya?
Offer a terse response. 39.64. What is the ratio of the Taxes (in US$) of 1963 in Iran to that in Kenya?
Offer a very short reply. 41.36. What is the ratio of the Taxes (in US$) in 1960 in Iran to that in Korea (Republic)?
Make the answer very short. 1.08. What is the ratio of the Taxes (in US$) in 1961 in Iran to that in Korea (Republic)?
Your answer should be compact. 1.06. What is the ratio of the Taxes (in US$) of 1962 in Iran to that in Korea (Republic)?
Your answer should be very brief. 0.74. What is the ratio of the Taxes (in US$) in 1963 in Iran to that in Korea (Republic)?
Ensure brevity in your answer.  0.73. What is the ratio of the Taxes (in US$) of 1960 in Iran to that in Madagascar?
Give a very brief answer. 6.95. What is the ratio of the Taxes (in US$) of 1961 in Iran to that in Madagascar?
Keep it short and to the point. 6.53. What is the ratio of the Taxes (in US$) in 1962 in Iran to that in Madagascar?
Provide a succinct answer. 6.18. What is the ratio of the Taxes (in US$) in 1963 in Iran to that in Madagascar?
Keep it short and to the point. 6.22. What is the ratio of the Taxes (in US$) of 1960 in Jamaica to that in Kenya?
Ensure brevity in your answer.  0.09. What is the ratio of the Taxes (in US$) of 1961 in Jamaica to that in Kenya?
Your response must be concise. 0.1. What is the ratio of the Taxes (in US$) in 1962 in Jamaica to that in Kenya?
Keep it short and to the point. 0.09. What is the ratio of the Taxes (in US$) in 1963 in Jamaica to that in Kenya?
Give a very brief answer. 0.09. What is the ratio of the Taxes (in US$) in 1960 in Jamaica to that in Korea (Republic)?
Provide a succinct answer. 0. What is the ratio of the Taxes (in US$) in 1961 in Jamaica to that in Korea (Republic)?
Offer a terse response. 0. What is the ratio of the Taxes (in US$) of 1962 in Jamaica to that in Korea (Republic)?
Provide a succinct answer. 0. What is the ratio of the Taxes (in US$) in 1963 in Jamaica to that in Korea (Republic)?
Make the answer very short. 0. What is the ratio of the Taxes (in US$) of 1960 in Jamaica to that in Madagascar?
Your answer should be compact. 0.01. What is the ratio of the Taxes (in US$) in 1961 in Jamaica to that in Madagascar?
Ensure brevity in your answer.  0.02. What is the ratio of the Taxes (in US$) of 1962 in Jamaica to that in Madagascar?
Provide a short and direct response. 0.01. What is the ratio of the Taxes (in US$) in 1963 in Jamaica to that in Madagascar?
Give a very brief answer. 0.01. What is the ratio of the Taxes (in US$) of 1960 in Kenya to that in Korea (Republic)?
Keep it short and to the point. 0.02. What is the ratio of the Taxes (in US$) of 1961 in Kenya to that in Korea (Republic)?
Keep it short and to the point. 0.03. What is the ratio of the Taxes (in US$) of 1962 in Kenya to that in Korea (Republic)?
Your answer should be compact. 0.02. What is the ratio of the Taxes (in US$) of 1963 in Kenya to that in Korea (Republic)?
Keep it short and to the point. 0.02. What is the ratio of the Taxes (in US$) in 1960 in Kenya to that in Madagascar?
Provide a short and direct response. 0.16. What is the ratio of the Taxes (in US$) of 1961 in Kenya to that in Madagascar?
Your answer should be compact. 0.16. What is the ratio of the Taxes (in US$) of 1962 in Kenya to that in Madagascar?
Your answer should be very brief. 0.16. What is the ratio of the Taxes (in US$) of 1963 in Kenya to that in Madagascar?
Your answer should be very brief. 0.15. What is the ratio of the Taxes (in US$) of 1960 in Korea (Republic) to that in Madagascar?
Provide a short and direct response. 6.45. What is the ratio of the Taxes (in US$) of 1961 in Korea (Republic) to that in Madagascar?
Your answer should be very brief. 6.15. What is the ratio of the Taxes (in US$) in 1962 in Korea (Republic) to that in Madagascar?
Give a very brief answer. 8.32. What is the ratio of the Taxes (in US$) of 1963 in Korea (Republic) to that in Madagascar?
Keep it short and to the point. 8.46. What is the difference between the highest and the second highest Taxes (in US$) in 1960?
Offer a very short reply. 1.31e+09. What is the difference between the highest and the second highest Taxes (in US$) of 1961?
Provide a short and direct response. 1.04e+09. What is the difference between the highest and the second highest Taxes (in US$) of 1962?
Your answer should be compact. 6.32e+09. What is the difference between the highest and the second highest Taxes (in US$) in 1963?
Your answer should be compact. 7.36e+09. What is the difference between the highest and the lowest Taxes (in US$) in 1960?
Offer a very short reply. 1.82e+1. What is the difference between the highest and the lowest Taxes (in US$) of 1961?
Give a very brief answer. 1.77e+1. What is the difference between the highest and the lowest Taxes (in US$) in 1962?
Ensure brevity in your answer.  2.46e+1. What is the difference between the highest and the lowest Taxes (in US$) of 1963?
Make the answer very short. 2.77e+1. 